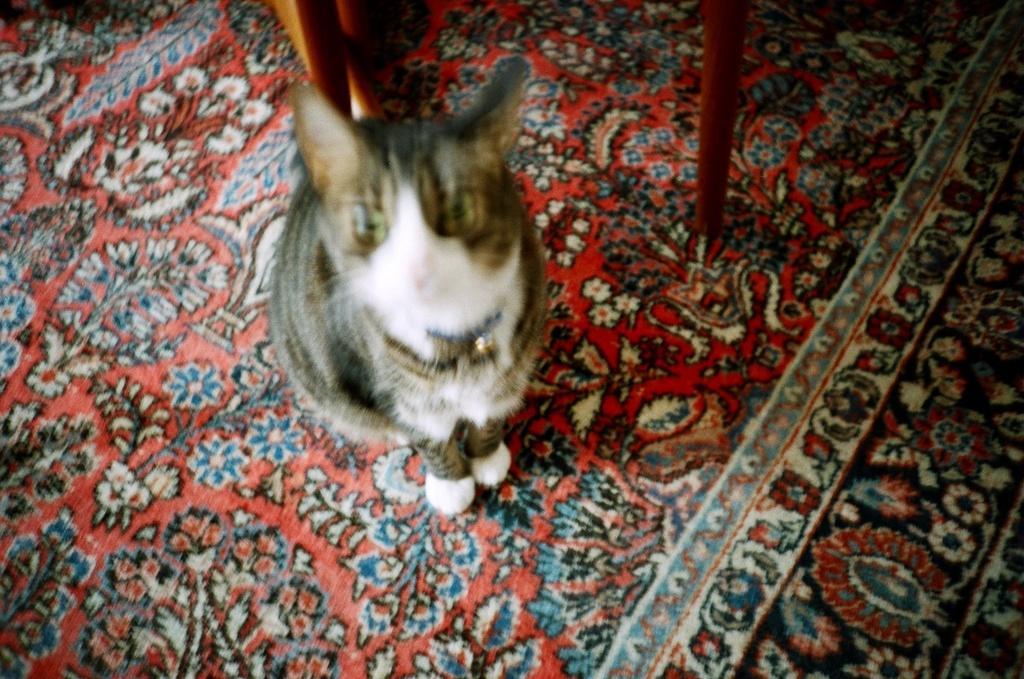Describe this image in one or two sentences. In this image I can see a cat which is white, black and grey in color is standing on the floor mat. I can see few brown colored objects which are made of wood. 